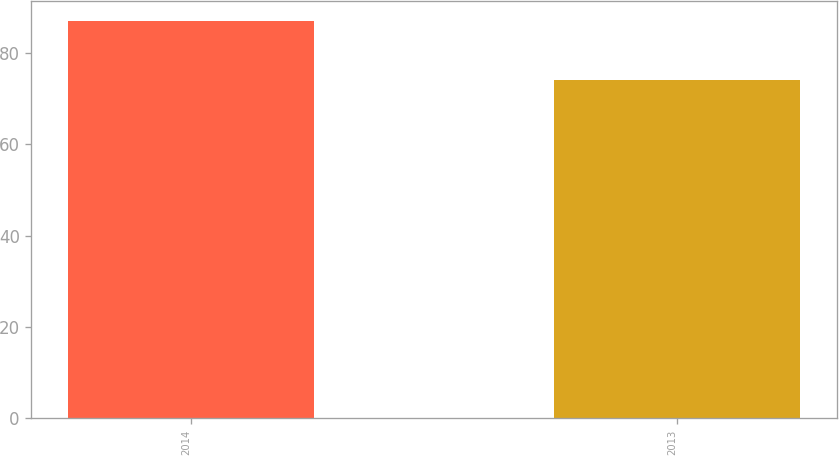Convert chart to OTSL. <chart><loc_0><loc_0><loc_500><loc_500><bar_chart><fcel>2014<fcel>2013<nl><fcel>87<fcel>74<nl></chart> 